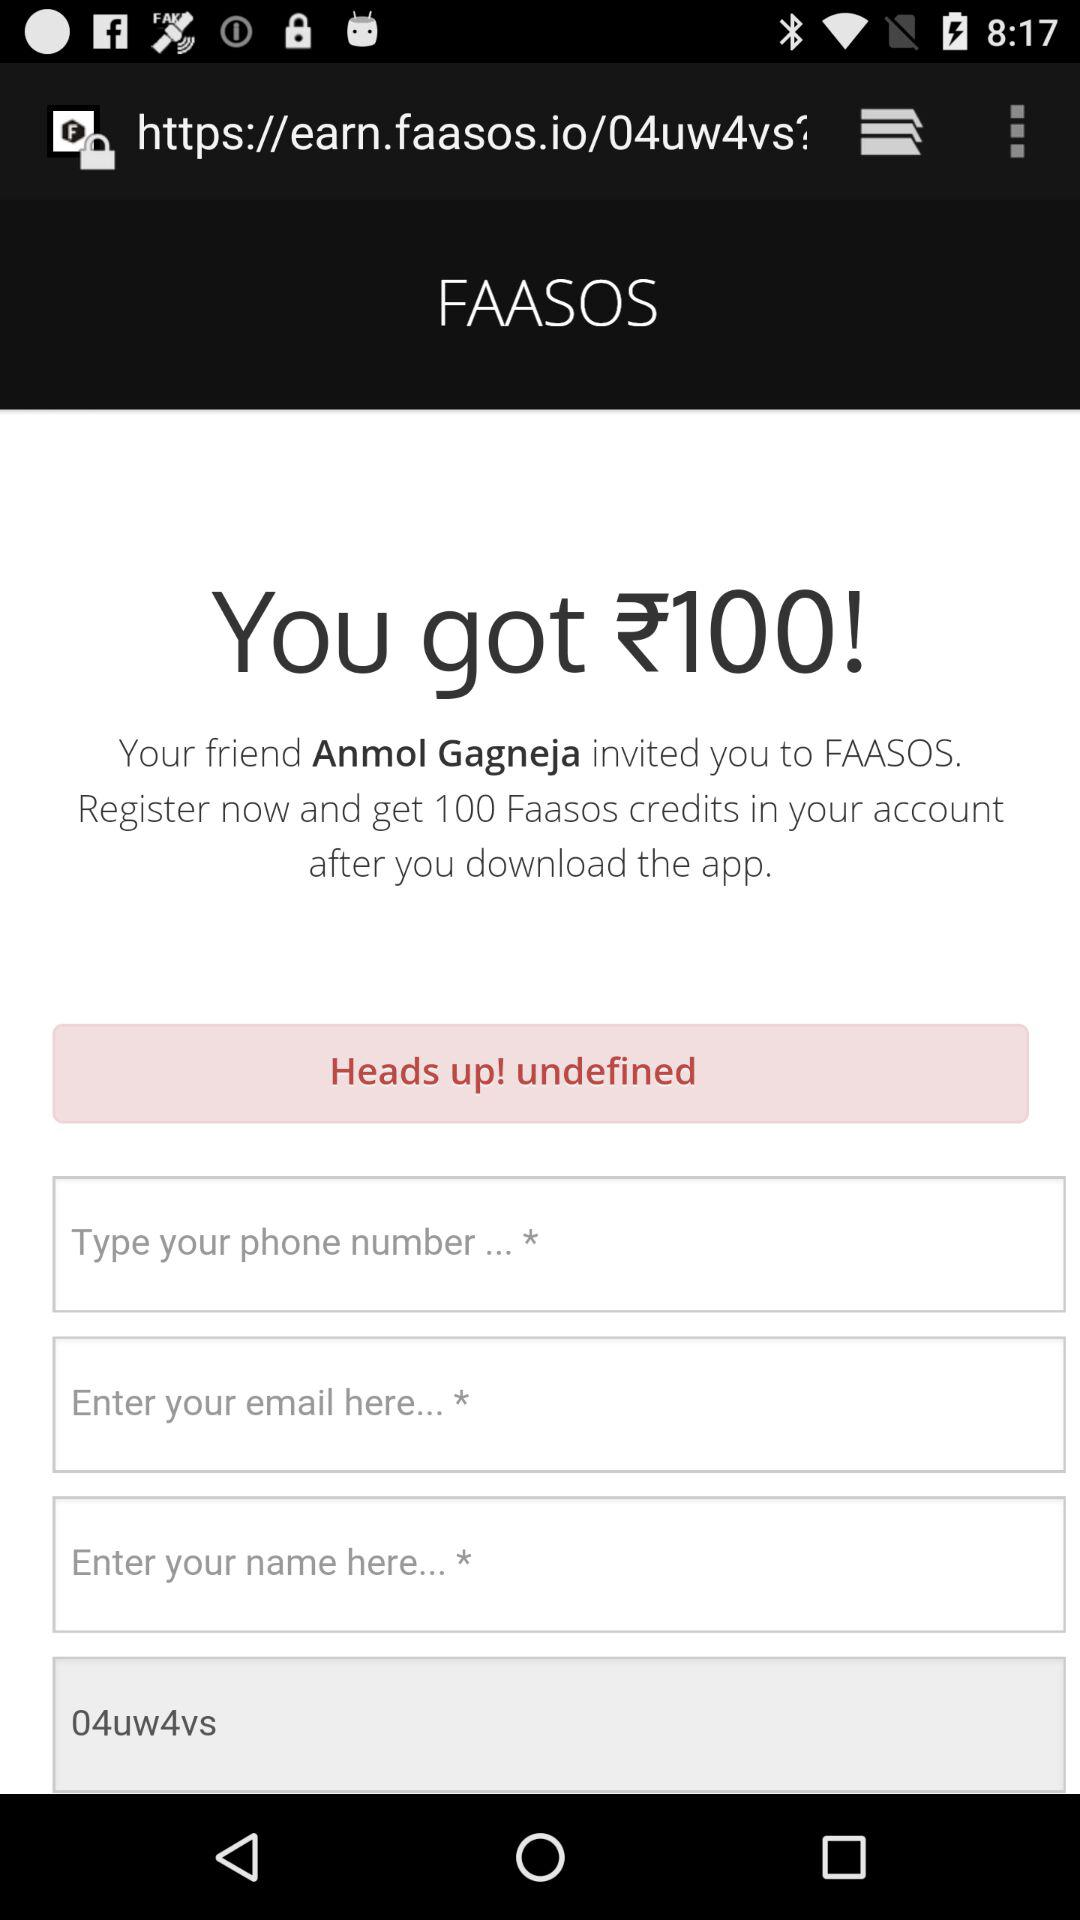Who invited me to "FAASOS"? You are invited to "FAASOS" by Anmol Gagneja. 